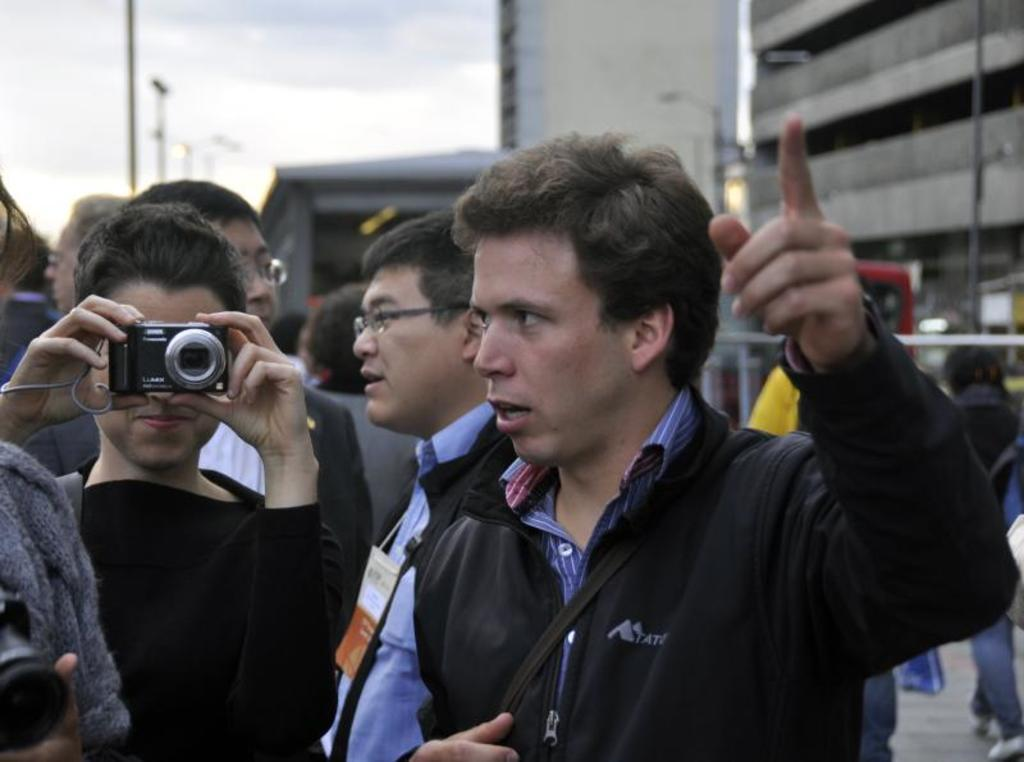How many people are in the image? There is a group of people standing in the image. What is the woman in the image holding? The woman is holding a camera in the image. What can be seen in the background of the image? There is a building and a pole in the background of the image. What is the condition of the sky in the image? The sky is cloudy in the image. What type of brick is being used to build the watch in the image? There is no watch or brick present in the image. 